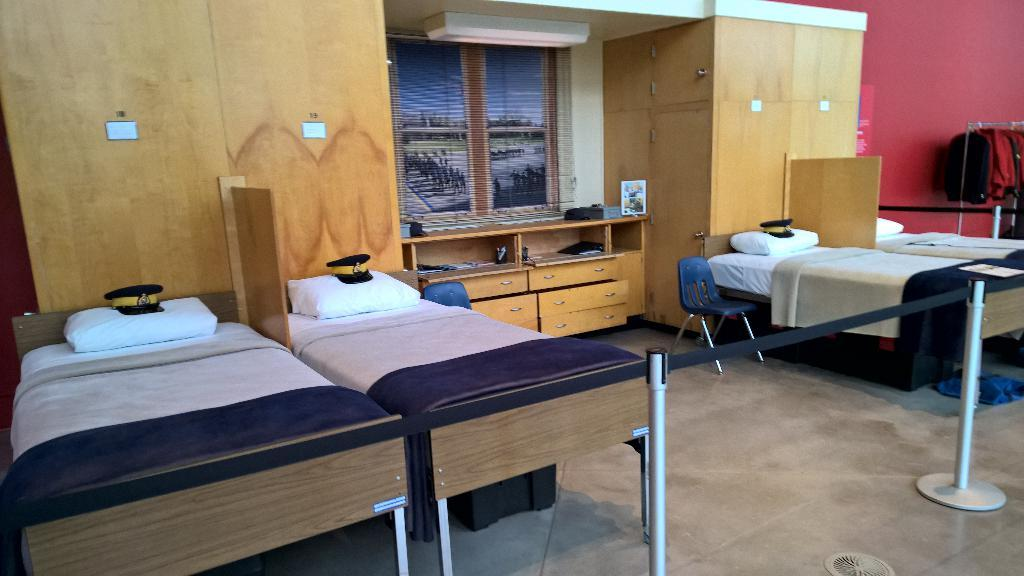How many beds are visible in the image? There are four beds in the image. What accompanies each bed in the image? There are four pillows in the image. What type of furniture is present for seating in the image? There are two chairs in the image. What can be seen in the background of the image? There is a cupboard and a window in the background of the image. What is the sister writing on the slope in the image? There is no sister, writing, or slope present in the image. 